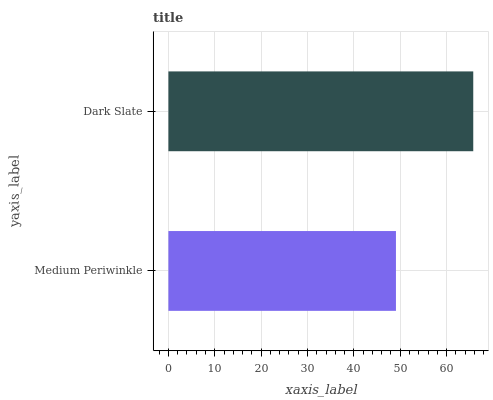Is Medium Periwinkle the minimum?
Answer yes or no. Yes. Is Dark Slate the maximum?
Answer yes or no. Yes. Is Dark Slate the minimum?
Answer yes or no. No. Is Dark Slate greater than Medium Periwinkle?
Answer yes or no. Yes. Is Medium Periwinkle less than Dark Slate?
Answer yes or no. Yes. Is Medium Periwinkle greater than Dark Slate?
Answer yes or no. No. Is Dark Slate less than Medium Periwinkle?
Answer yes or no. No. Is Dark Slate the high median?
Answer yes or no. Yes. Is Medium Periwinkle the low median?
Answer yes or no. Yes. Is Medium Periwinkle the high median?
Answer yes or no. No. Is Dark Slate the low median?
Answer yes or no. No. 